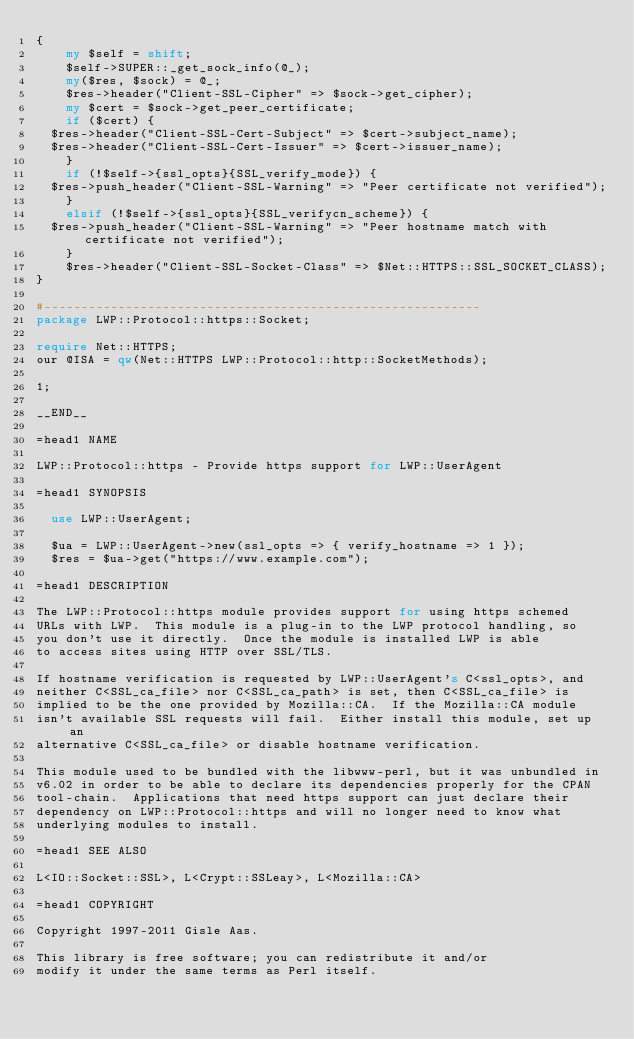Convert code to text. <code><loc_0><loc_0><loc_500><loc_500><_Perl_>{
    my $self = shift;
    $self->SUPER::_get_sock_info(@_);
    my($res, $sock) = @_;
    $res->header("Client-SSL-Cipher" => $sock->get_cipher);
    my $cert = $sock->get_peer_certificate;
    if ($cert) {
	$res->header("Client-SSL-Cert-Subject" => $cert->subject_name);
	$res->header("Client-SSL-Cert-Issuer" => $cert->issuer_name);
    }
    if (!$self->{ssl_opts}{SSL_verify_mode}) {
	$res->push_header("Client-SSL-Warning" => "Peer certificate not verified");
    }
    elsif (!$self->{ssl_opts}{SSL_verifycn_scheme}) {
	$res->push_header("Client-SSL-Warning" => "Peer hostname match with certificate not verified");
    }
    $res->header("Client-SSL-Socket-Class" => $Net::HTTPS::SSL_SOCKET_CLASS);
}

#-----------------------------------------------------------
package LWP::Protocol::https::Socket;

require Net::HTTPS;
our @ISA = qw(Net::HTTPS LWP::Protocol::http::SocketMethods);

1;

__END__

=head1 NAME

LWP::Protocol::https - Provide https support for LWP::UserAgent

=head1 SYNOPSIS

  use LWP::UserAgent;

  $ua = LWP::UserAgent->new(ssl_opts => { verify_hostname => 1 });
  $res = $ua->get("https://www.example.com");

=head1 DESCRIPTION

The LWP::Protocol::https module provides support for using https schemed
URLs with LWP.  This module is a plug-in to the LWP protocol handling, so
you don't use it directly.  Once the module is installed LWP is able
to access sites using HTTP over SSL/TLS.

If hostname verification is requested by LWP::UserAgent's C<ssl_opts>, and
neither C<SSL_ca_file> nor C<SSL_ca_path> is set, then C<SSL_ca_file> is
implied to be the one provided by Mozilla::CA.  If the Mozilla::CA module
isn't available SSL requests will fail.  Either install this module, set up an
alternative C<SSL_ca_file> or disable hostname verification.

This module used to be bundled with the libwww-perl, but it was unbundled in
v6.02 in order to be able to declare its dependencies properly for the CPAN
tool-chain.  Applications that need https support can just declare their
dependency on LWP::Protocol::https and will no longer need to know what
underlying modules to install.

=head1 SEE ALSO

L<IO::Socket::SSL>, L<Crypt::SSLeay>, L<Mozilla::CA>

=head1 COPYRIGHT

Copyright 1997-2011 Gisle Aas.

This library is free software; you can redistribute it and/or
modify it under the same terms as Perl itself.
</code> 